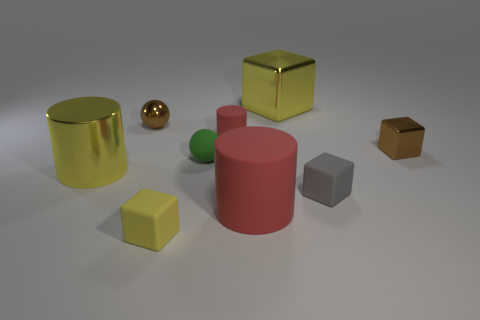How many rubber balls are the same color as the big metal cube?
Offer a terse response. 0. Does the green sphere have the same material as the tiny gray cube?
Your answer should be compact. Yes. How many red cylinders are in front of the tiny green thing behind the big red object?
Make the answer very short. 1. Does the brown metal ball have the same size as the gray matte thing?
Provide a succinct answer. Yes. How many small yellow things are made of the same material as the tiny green ball?
Make the answer very short. 1. What size is the metallic object that is the same shape as the small red matte thing?
Provide a short and direct response. Large. Is the shape of the small thing to the left of the yellow rubber object the same as  the large red object?
Offer a very short reply. No. What is the shape of the yellow metallic thing that is behind the metallic object in front of the small brown metallic block?
Your answer should be very brief. Cube. Are there any other things that are the same shape as the tiny green thing?
Offer a very short reply. Yes. What is the color of the other matte object that is the same shape as the gray thing?
Give a very brief answer. Yellow. 